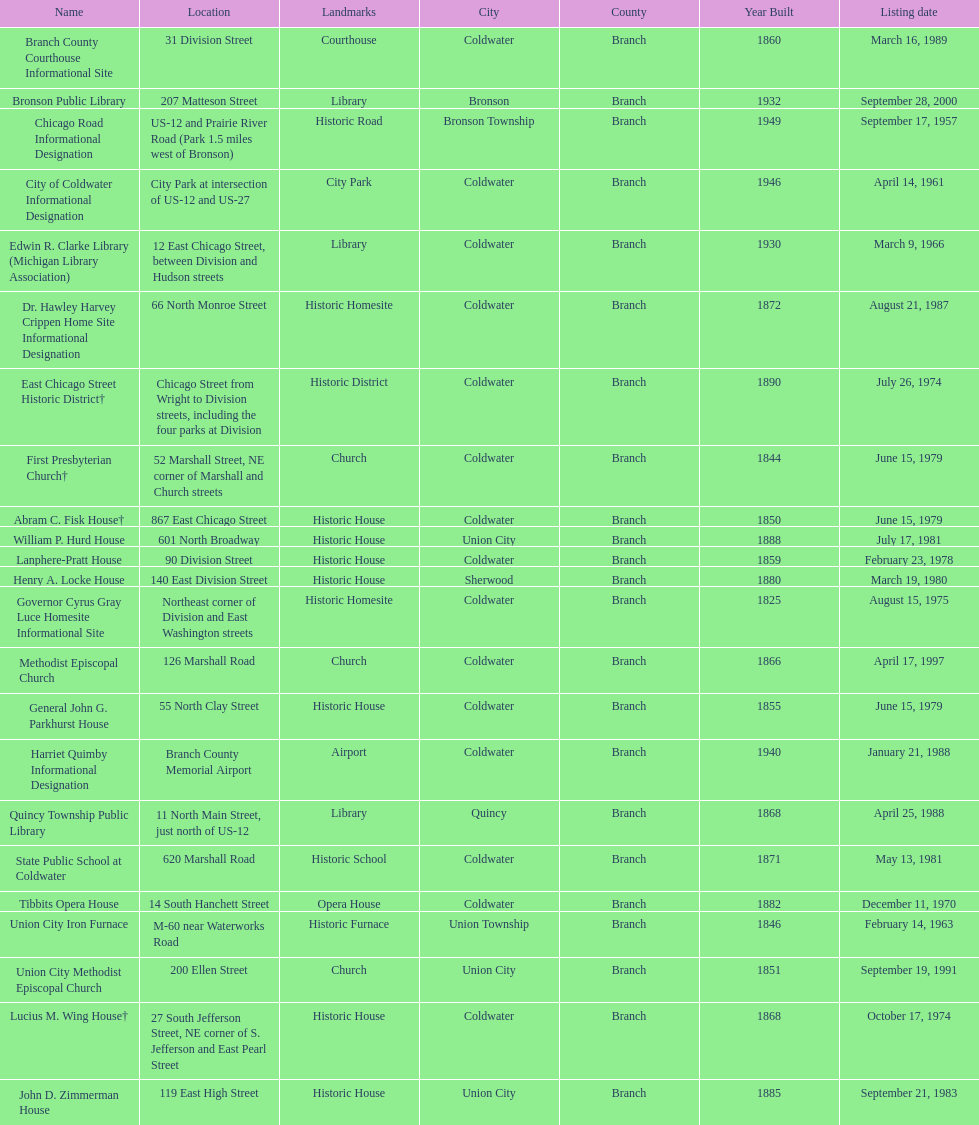Which city has the largest number of historic sites? Coldwater. 